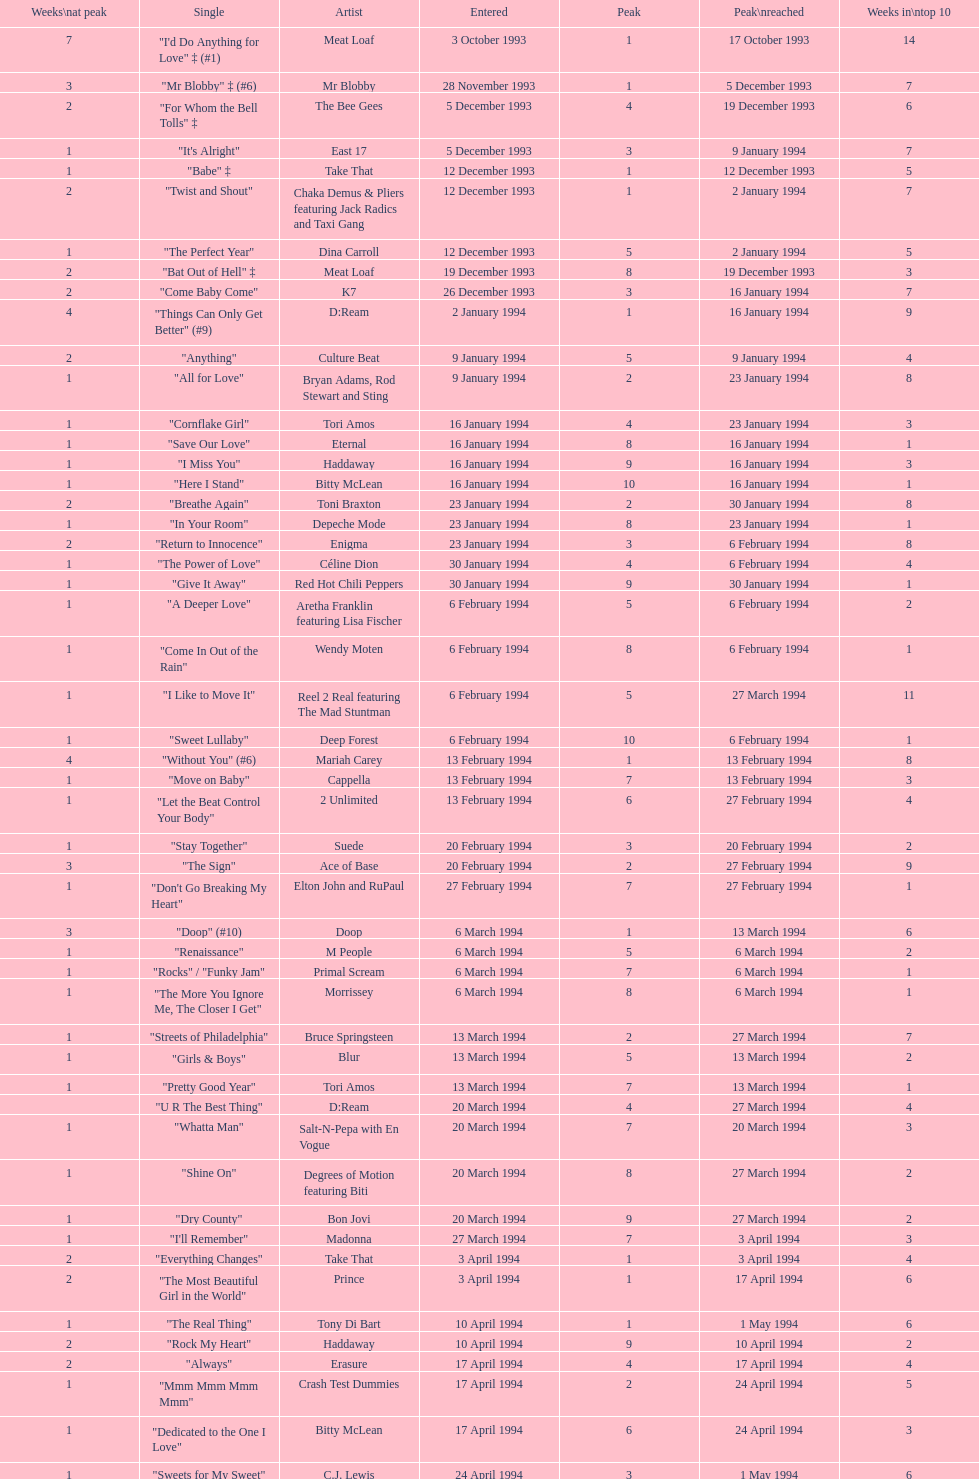Which artist only has its single entered on 2 january 1994? D:Ream. 